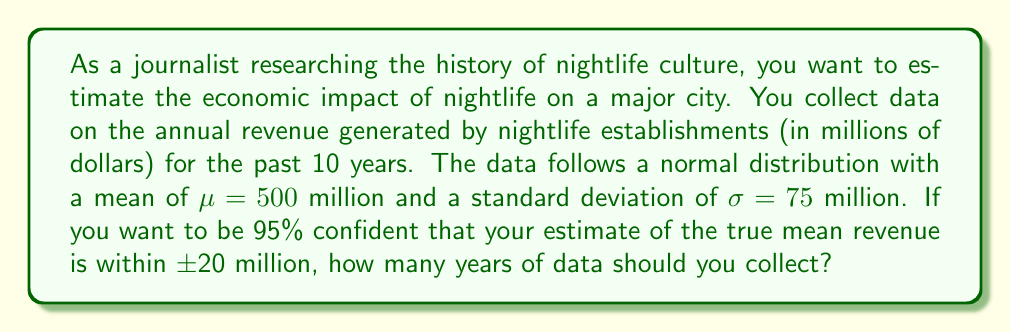Solve this math problem. To solve this problem, we'll use the formula for the margin of error in a confidence interval for a normal distribution:

$$E = z_{\alpha/2} \cdot \frac{\sigma}{\sqrt{n}}$$

Where:
- $E$ is the margin of error (20 million in this case)
- $z_{\alpha/2}$ is the z-score for a 95% confidence interval (1.96)
- $\sigma$ is the standard deviation (75 million)
- $n$ is the sample size (number of years we need to determine)

Step 1: Substitute the known values into the formula:

$$20 = 1.96 \cdot \frac{75}{\sqrt{n}}$$

Step 2: Solve for $n$:

$$\sqrt{n} = \frac{1.96 \cdot 75}{20}$$

$$n = \left(\frac{1.96 \cdot 75}{20}\right)^2$$

Step 3: Calculate the result:

$$n = \left(\frac{147}{20}\right)^2 = 7.35^2 = 54.0225$$

Step 4: Round up to the nearest whole number, as we can't collect partial years of data:

$n = 55$

Therefore, you should collect 55 years of data to be 95% confident that your estimate of the true mean revenue is within $\pm$20 million.
Answer: 55 years 